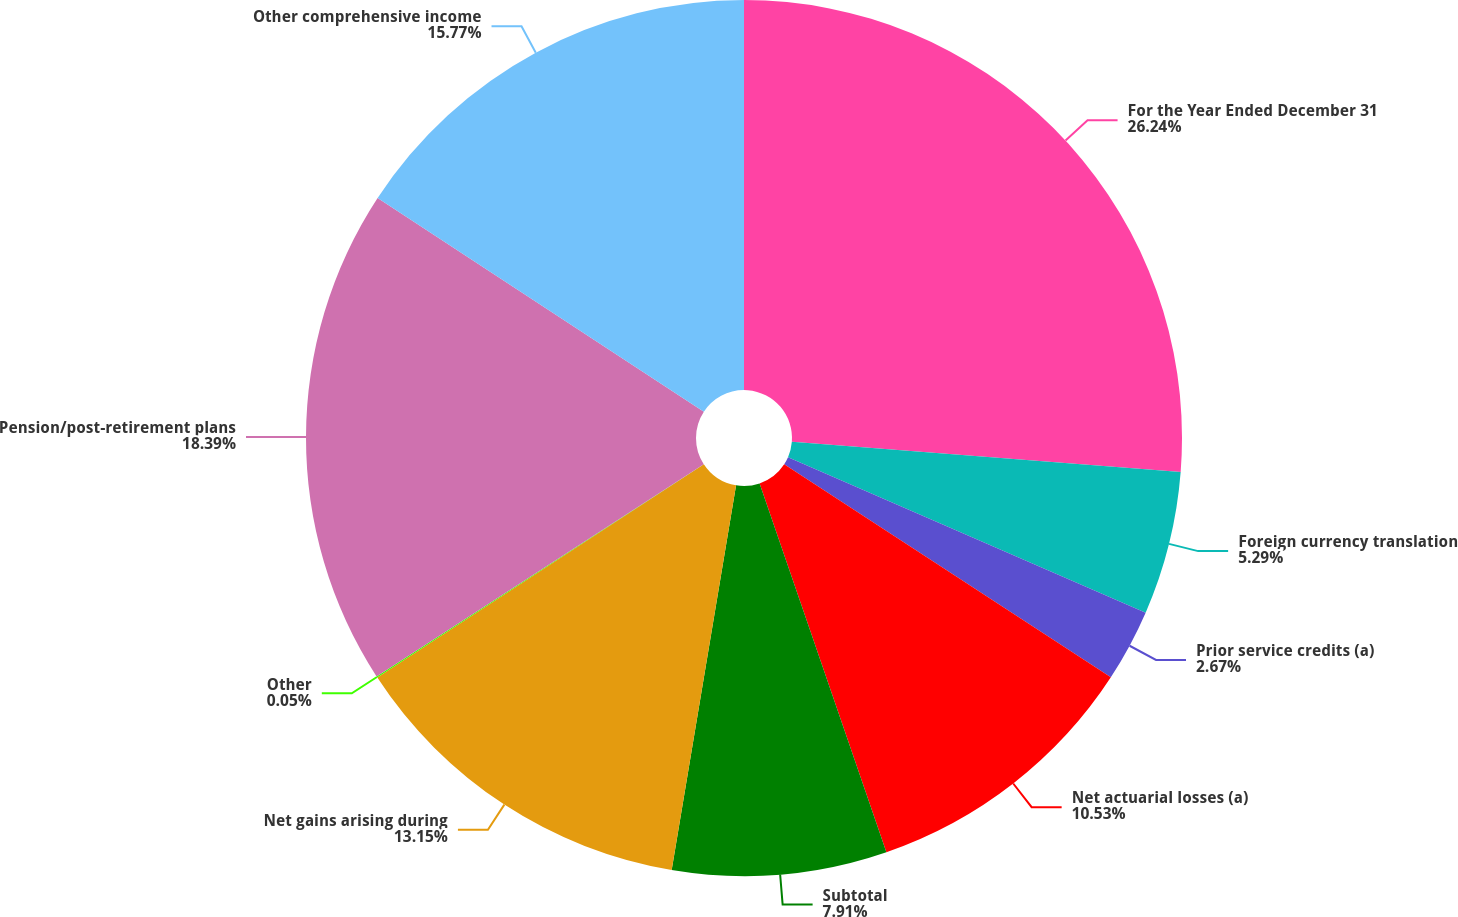Convert chart to OTSL. <chart><loc_0><loc_0><loc_500><loc_500><pie_chart><fcel>For the Year Ended December 31<fcel>Foreign currency translation<fcel>Prior service credits (a)<fcel>Net actuarial losses (a)<fcel>Subtotal<fcel>Net gains arising during<fcel>Other<fcel>Pension/post-retirement plans<fcel>Other comprehensive income<nl><fcel>26.24%<fcel>5.29%<fcel>2.67%<fcel>10.53%<fcel>7.91%<fcel>13.15%<fcel>0.05%<fcel>18.39%<fcel>15.77%<nl></chart> 